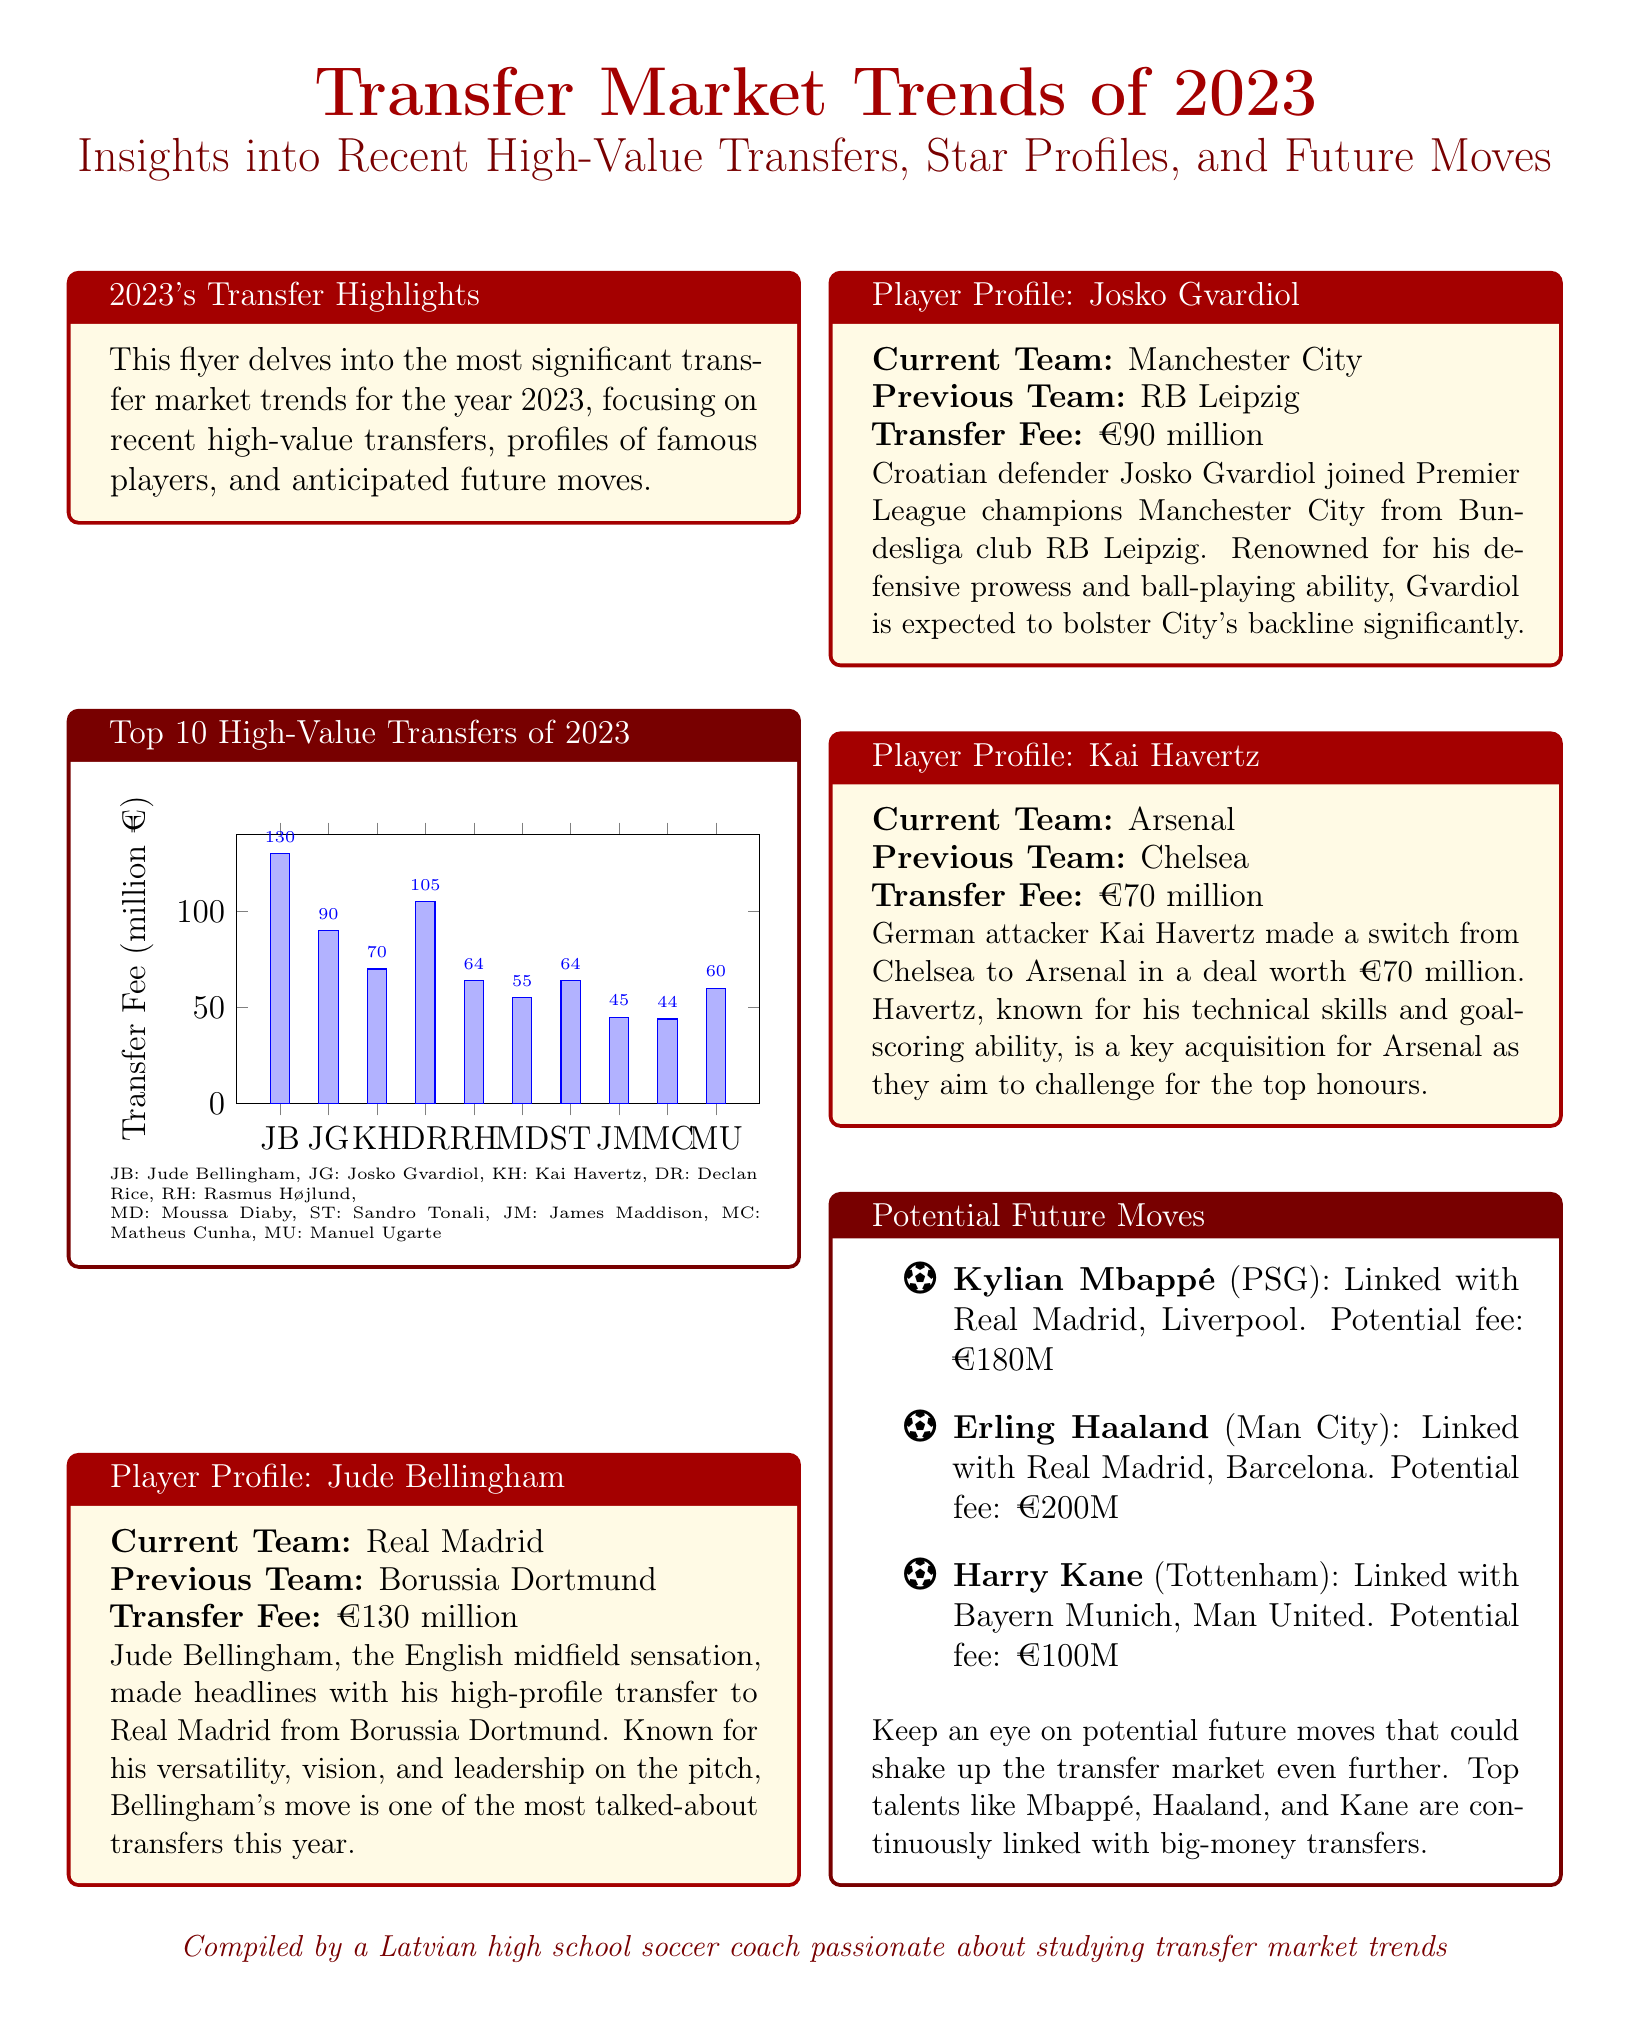What is the highest transfer fee in 2023? The highest transfer fee listed in the document is €130 million for Jude Bellingham.
Answer: €130 million Which player transferred to Manchester City in 2023? The document states that Josko Gvardiol transferred to Manchester City from RB Leipzig.
Answer: Josko Gvardiol What potential fee is Kylian Mbappé linked with? The document indicates that Kylian Mbappé has a potential fee of €180 million.
Answer: €180 million How many players are mentioned in the Top 10 High-Value Transfers section? The Top 10 High-Value Transfers section includes 10 players listed.
Answer: 10 players Which player is noted for his versatility and leadership? Jude Bellingham is highlighted for his versatility, vision, and leadership on the pitch.
Answer: Jude Bellingham Which club did Kai Havertz transfer from? According to the document, Kai Havertz transferred from Chelsea.
Answer: Chelsea What is the total transfer fee of the top three listed players? The total transfer fee is calculated as 130 (Bellingham) + 90 (Gvardiol) + 70 (Havertz) = €290 million.
Answer: €290 million What color is used for the section titles in the flyer? The section titles in the flyer use latvianred color for visibility.
Answer: latvianred Which player has a potential fee of €200 million? The document states that Erling Haaland has a potential fee of €200 million.
Answer: Erling Haaland 